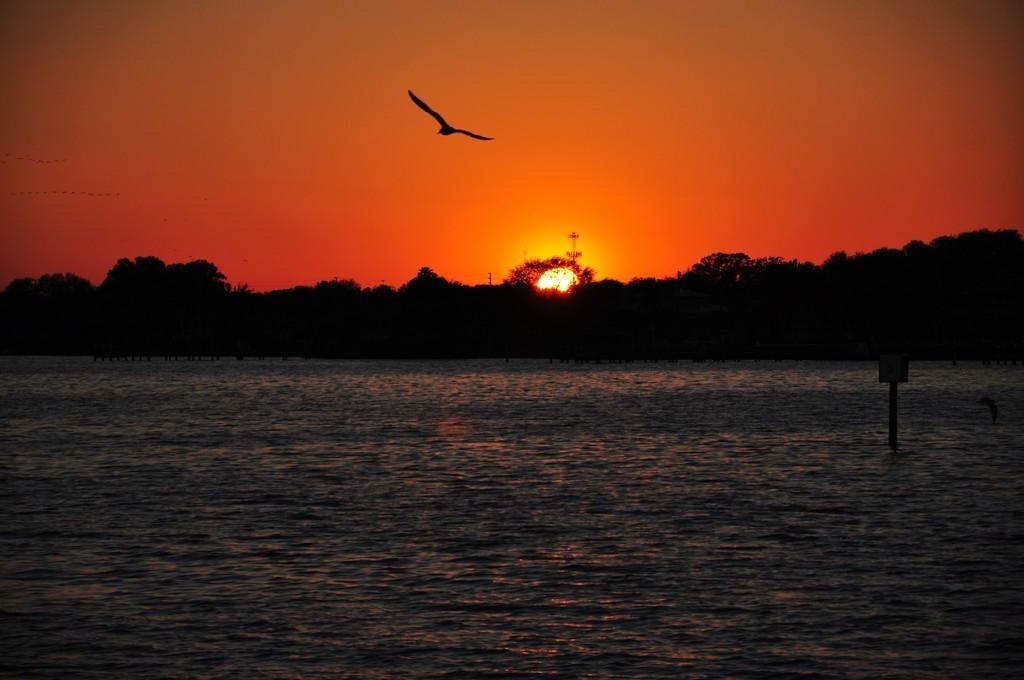Can you describe this image briefly? In this picture we can see a bird is flying the air and behind the bird there is water, trees and a sky. 